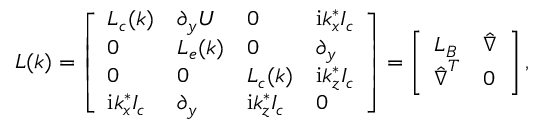<formula> <loc_0><loc_0><loc_500><loc_500>L ( k ) = \left [ \begin{array} { l l l l } { L _ { c } ( k ) } & { \partial _ { y } U } & { 0 } & { i k _ { x } ^ { * } I _ { c } } \\ { 0 } & { L _ { e } ( k ) } & { 0 } & { \partial _ { y } } \\ { 0 } & { 0 } & { L _ { c } ( k ) } & { i k _ { z } ^ { * } I _ { c } } \\ { i k _ { x } ^ { * } I _ { c } } & { \partial _ { y } } & { i k _ { z } ^ { * } I _ { c } } & { 0 } \end{array} \right ] = \left [ \begin{array} { l l } { L _ { B } } & { \hat { \nabla } } \\ { \hat { \nabla } ^ { T } } & { 0 } \end{array} \right ] ,</formula> 